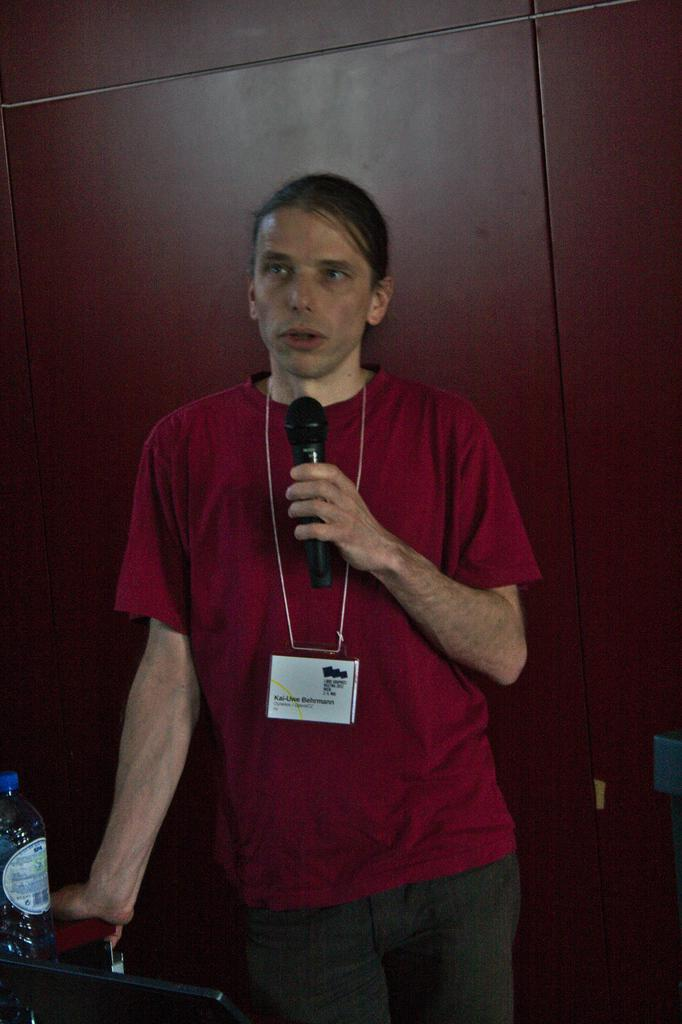What is the person in the image wearing on their upper body? The person is wearing a red shirt in the image. What object is the person holding in their hand? The person is holding a microphone in their hand. What is the person doing in the image? The person is talking in the image. What can be seen to the left side of the image? There is a water bottle to the left side of the image. What type of identification is the person wearing? The person is wearing a white color identity card. What type of poison is the person using to answer questions in the image? There is no poison present in the image, and the person is not answering questions. 